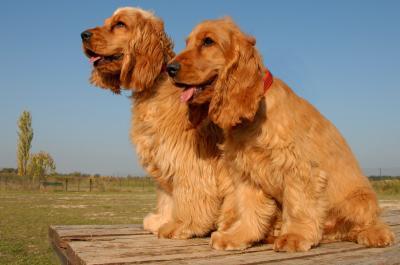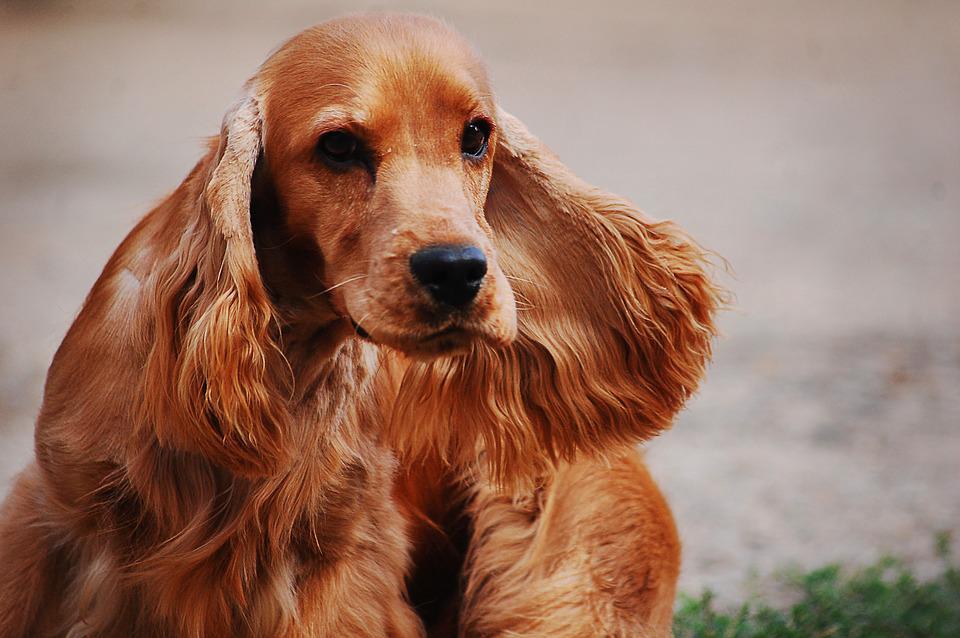The first image is the image on the left, the second image is the image on the right. Considering the images on both sides, is "There are three dogs" valid? Answer yes or no. Yes. 